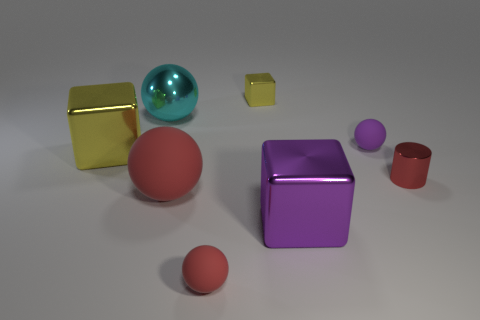Subtract 1 spheres. How many spheres are left? 3 Add 1 brown shiny cubes. How many objects exist? 9 Subtract all cubes. How many objects are left? 5 Add 6 big balls. How many big balls are left? 8 Add 1 metal cylinders. How many metal cylinders exist? 2 Subtract 0 cyan cylinders. How many objects are left? 8 Subtract all small red cylinders. Subtract all big things. How many objects are left? 3 